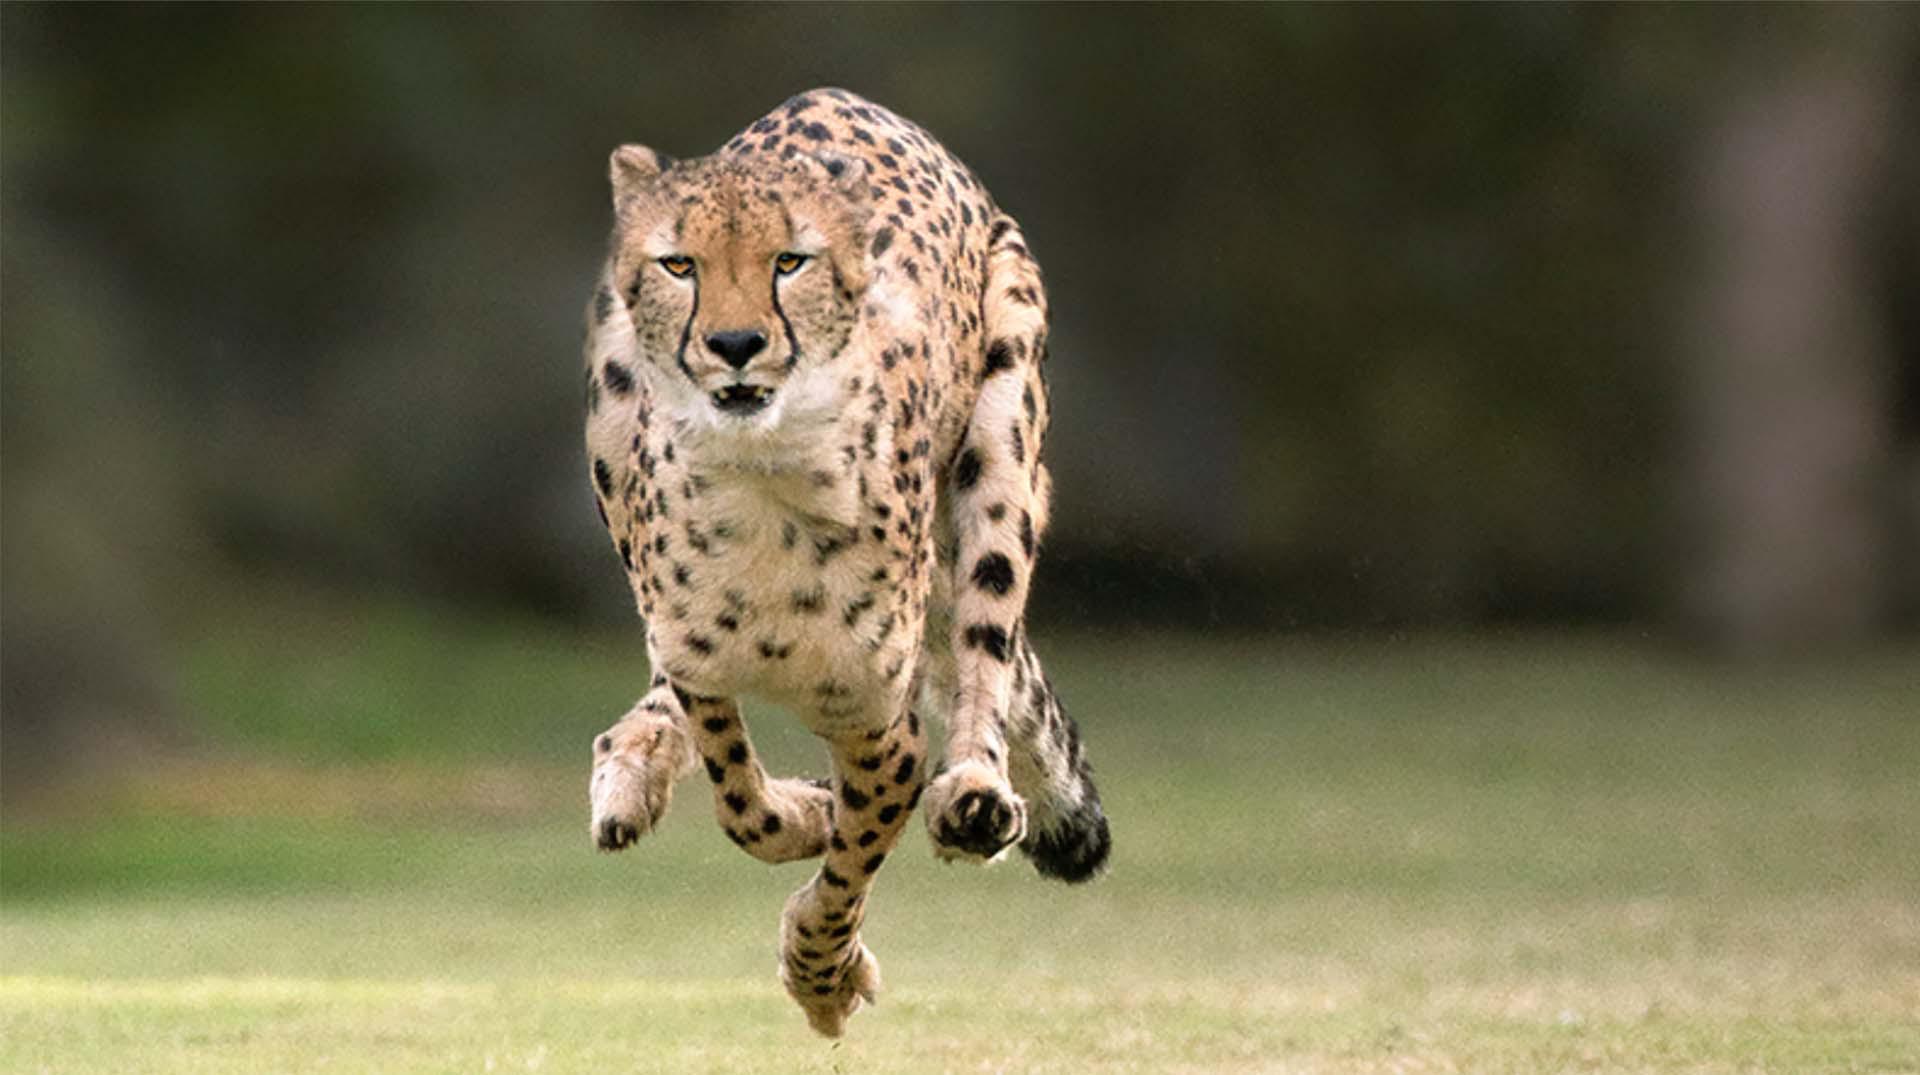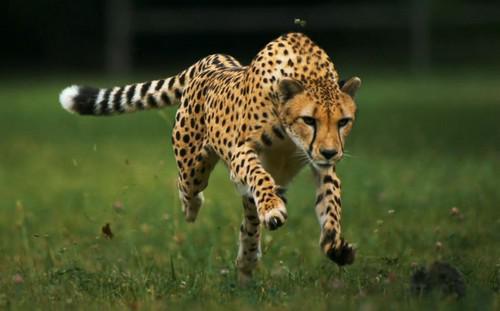The first image is the image on the left, the second image is the image on the right. For the images shown, is this caption "At least one of the animals is in mid-leap." true? Answer yes or no. Yes. 